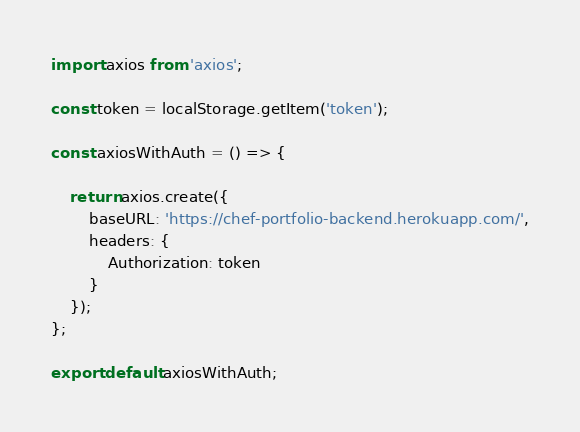<code> <loc_0><loc_0><loc_500><loc_500><_JavaScript_>import axios from 'axios';

const token = localStorage.getItem('token');

const axiosWithAuth = () => {
    
    return axios.create({
        baseURL: 'https://chef-portfolio-backend.herokuapp.com/',
        headers: {
            Authorization: token
        }
    });
};

export default axiosWithAuth;</code> 